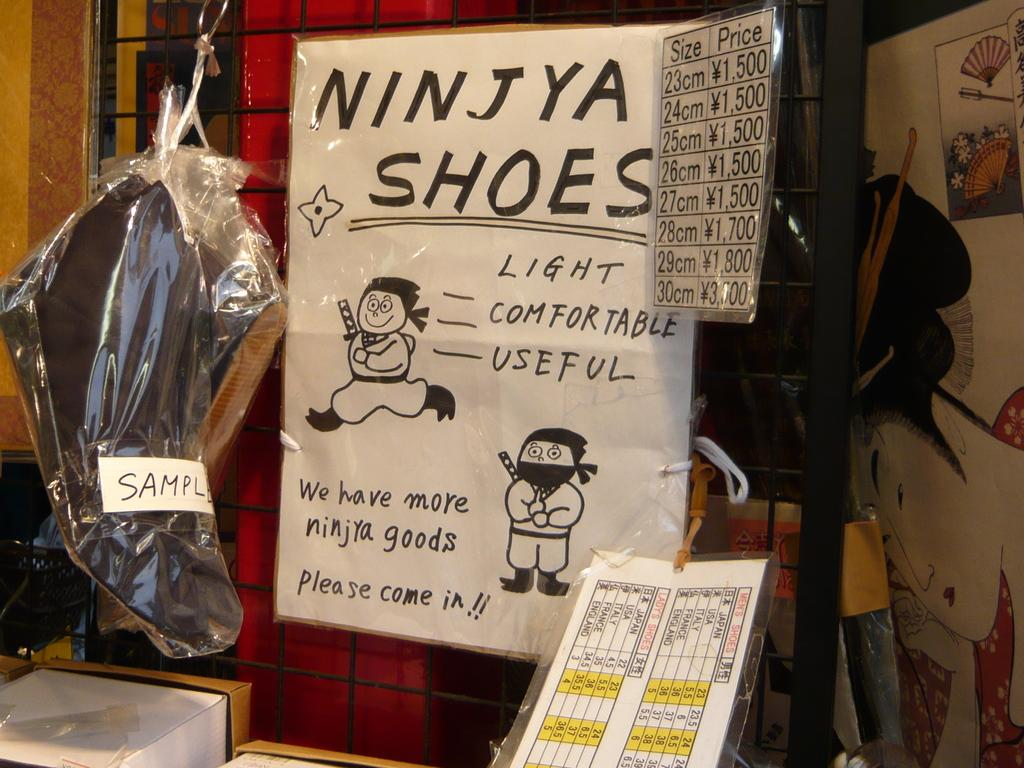Provide a one-sentence caption for the provided image. A handmade ad for Ninjya Shoes is posted next to a price list. 